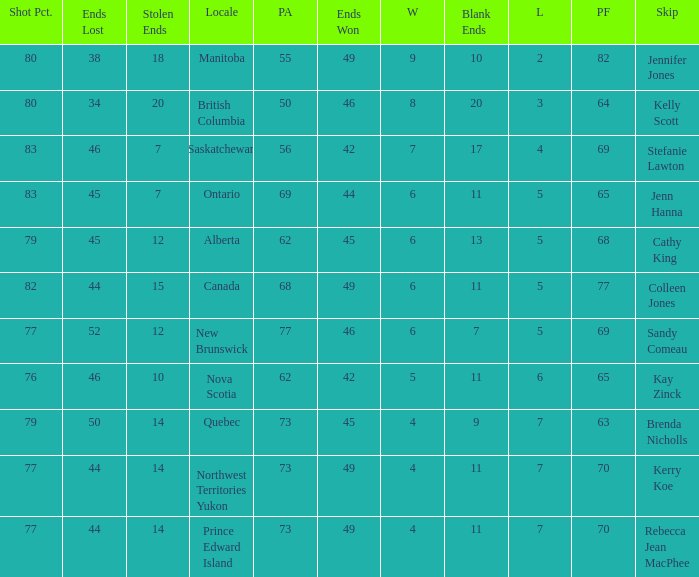What is the total number of ends won when the locale is Northwest Territories Yukon? 1.0. 